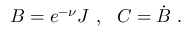Convert formula to latex. <formula><loc_0><loc_0><loc_500><loc_500>B = e ^ { - \nu } J \ , \ \ C = \dot { B } \ .</formula> 